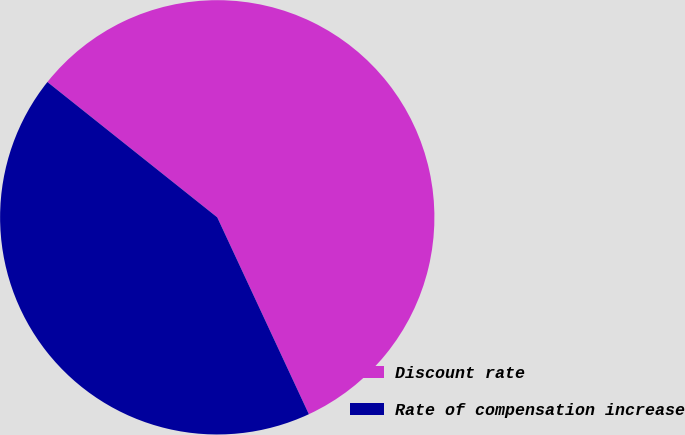Convert chart to OTSL. <chart><loc_0><loc_0><loc_500><loc_500><pie_chart><fcel>Discount rate<fcel>Rate of compensation increase<nl><fcel>57.36%<fcel>42.64%<nl></chart> 